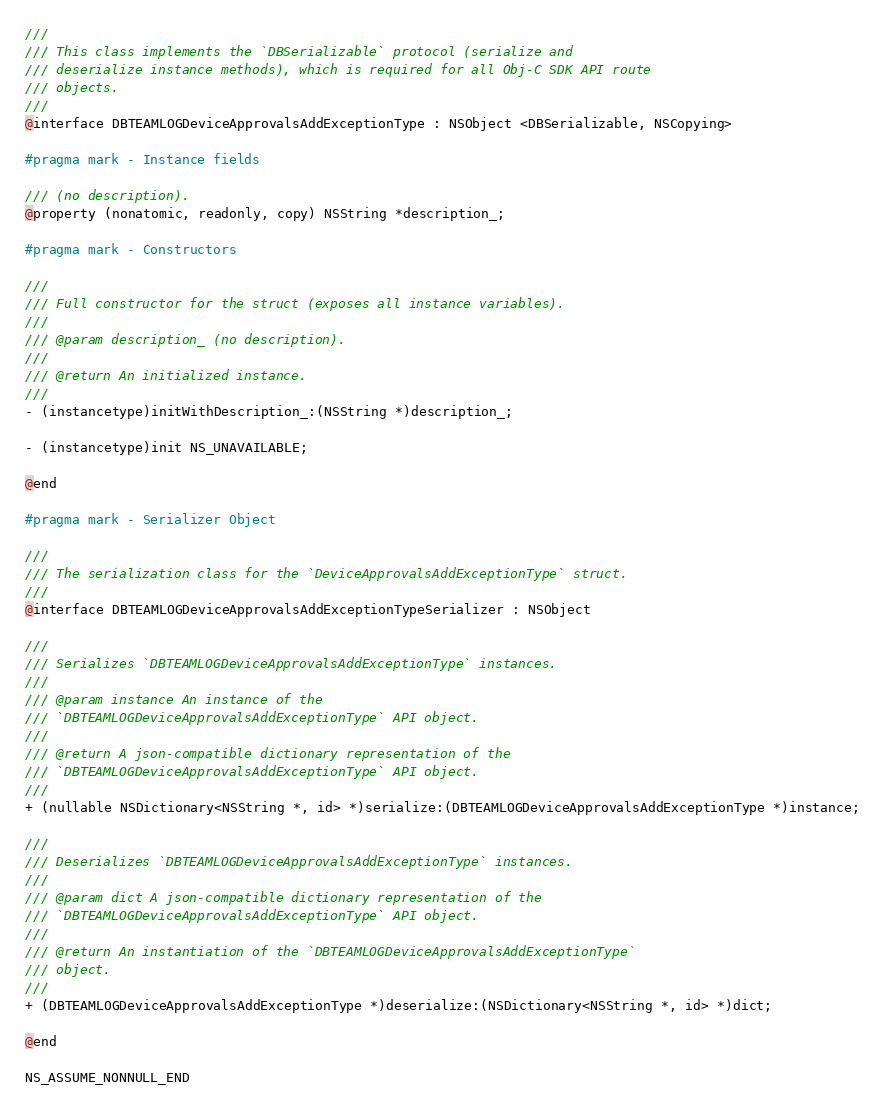Convert code to text. <code><loc_0><loc_0><loc_500><loc_500><_C_>///
/// This class implements the `DBSerializable` protocol (serialize and
/// deserialize instance methods), which is required for all Obj-C SDK API route
/// objects.
///
@interface DBTEAMLOGDeviceApprovalsAddExceptionType : NSObject <DBSerializable, NSCopying>

#pragma mark - Instance fields

/// (no description).
@property (nonatomic, readonly, copy) NSString *description_;

#pragma mark - Constructors

///
/// Full constructor for the struct (exposes all instance variables).
///
/// @param description_ (no description).
///
/// @return An initialized instance.
///
- (instancetype)initWithDescription_:(NSString *)description_;

- (instancetype)init NS_UNAVAILABLE;

@end

#pragma mark - Serializer Object

///
/// The serialization class for the `DeviceApprovalsAddExceptionType` struct.
///
@interface DBTEAMLOGDeviceApprovalsAddExceptionTypeSerializer : NSObject

///
/// Serializes `DBTEAMLOGDeviceApprovalsAddExceptionType` instances.
///
/// @param instance An instance of the
/// `DBTEAMLOGDeviceApprovalsAddExceptionType` API object.
///
/// @return A json-compatible dictionary representation of the
/// `DBTEAMLOGDeviceApprovalsAddExceptionType` API object.
///
+ (nullable NSDictionary<NSString *, id> *)serialize:(DBTEAMLOGDeviceApprovalsAddExceptionType *)instance;

///
/// Deserializes `DBTEAMLOGDeviceApprovalsAddExceptionType` instances.
///
/// @param dict A json-compatible dictionary representation of the
/// `DBTEAMLOGDeviceApprovalsAddExceptionType` API object.
///
/// @return An instantiation of the `DBTEAMLOGDeviceApprovalsAddExceptionType`
/// object.
///
+ (DBTEAMLOGDeviceApprovalsAddExceptionType *)deserialize:(NSDictionary<NSString *, id> *)dict;

@end

NS_ASSUME_NONNULL_END
</code> 